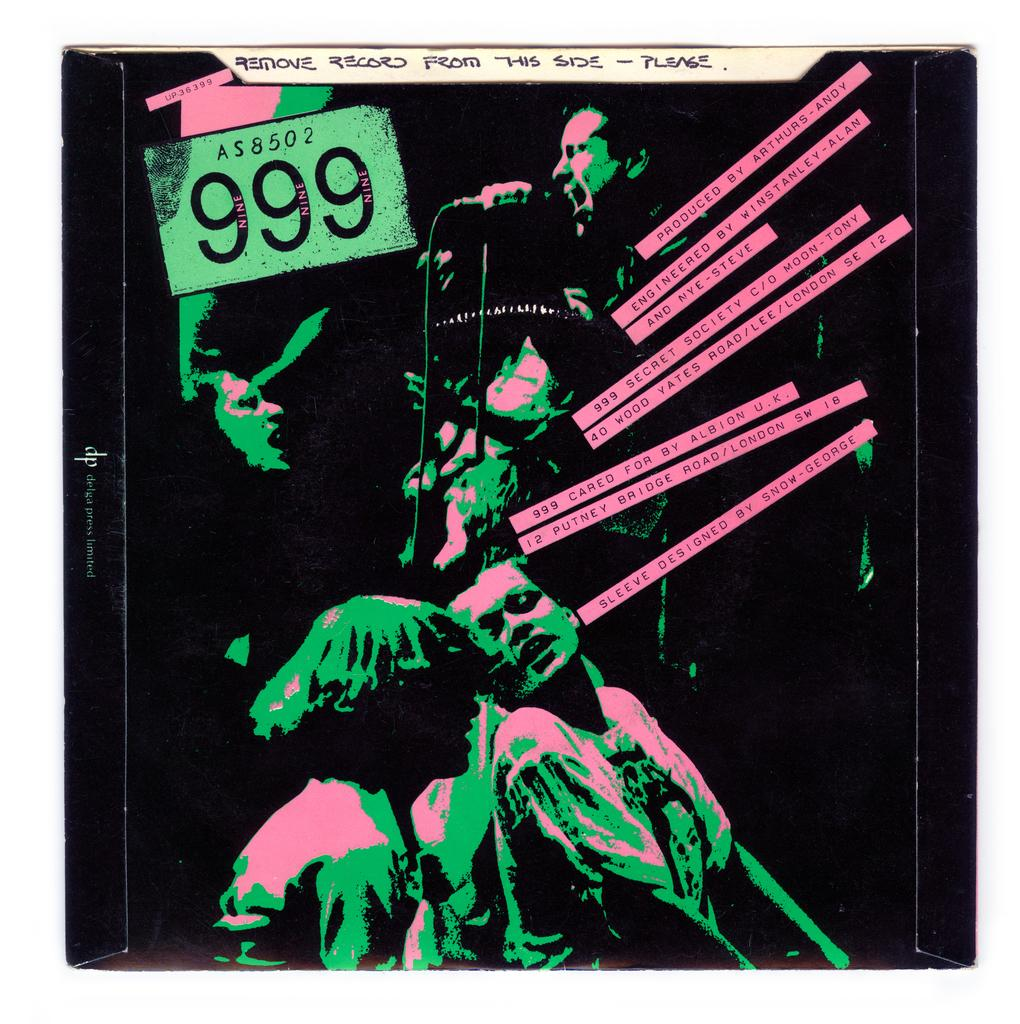<image>
Give a short and clear explanation of the subsequent image. A record entitled 999 Secret Society produced by Arthurs-Andy. 